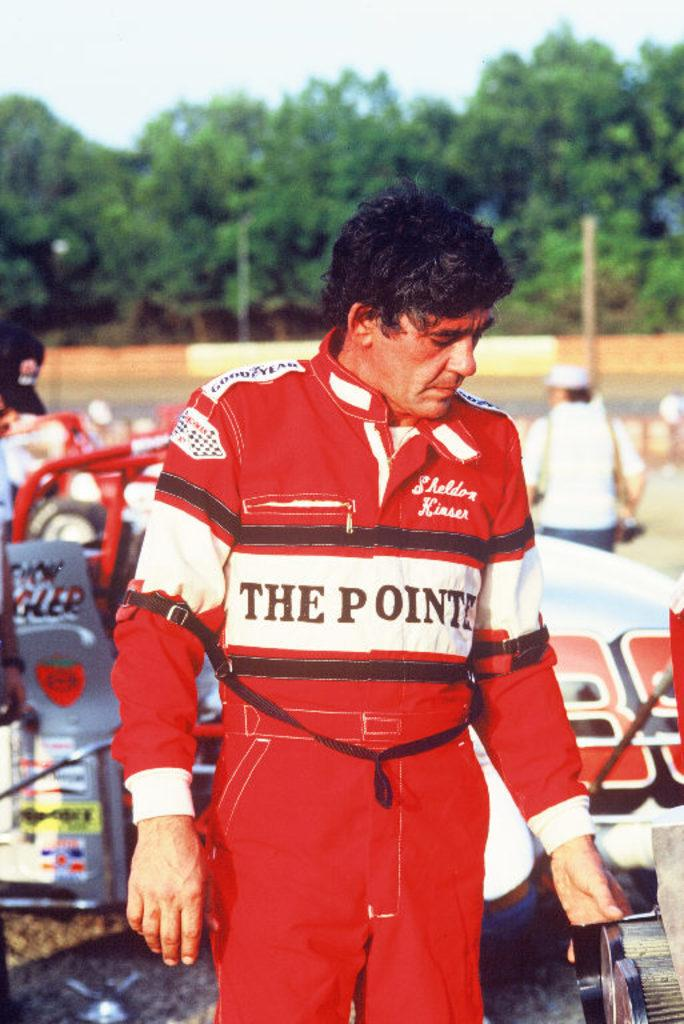<image>
Offer a succinct explanation of the picture presented. a man named sheldon kiaser in a red jumpsuit in front of a racecar 